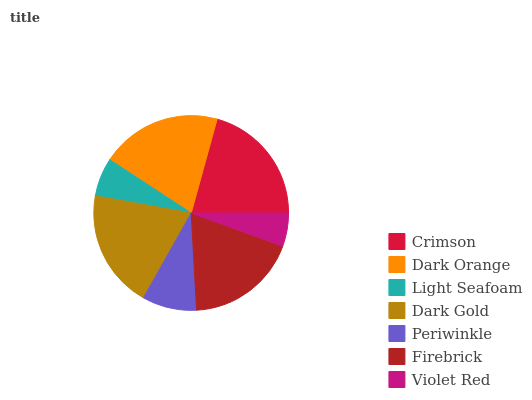Is Violet Red the minimum?
Answer yes or no. Yes. Is Crimson the maximum?
Answer yes or no. Yes. Is Dark Orange the minimum?
Answer yes or no. No. Is Dark Orange the maximum?
Answer yes or no. No. Is Crimson greater than Dark Orange?
Answer yes or no. Yes. Is Dark Orange less than Crimson?
Answer yes or no. Yes. Is Dark Orange greater than Crimson?
Answer yes or no. No. Is Crimson less than Dark Orange?
Answer yes or no. No. Is Firebrick the high median?
Answer yes or no. Yes. Is Firebrick the low median?
Answer yes or no. Yes. Is Dark Gold the high median?
Answer yes or no. No. Is Violet Red the low median?
Answer yes or no. No. 